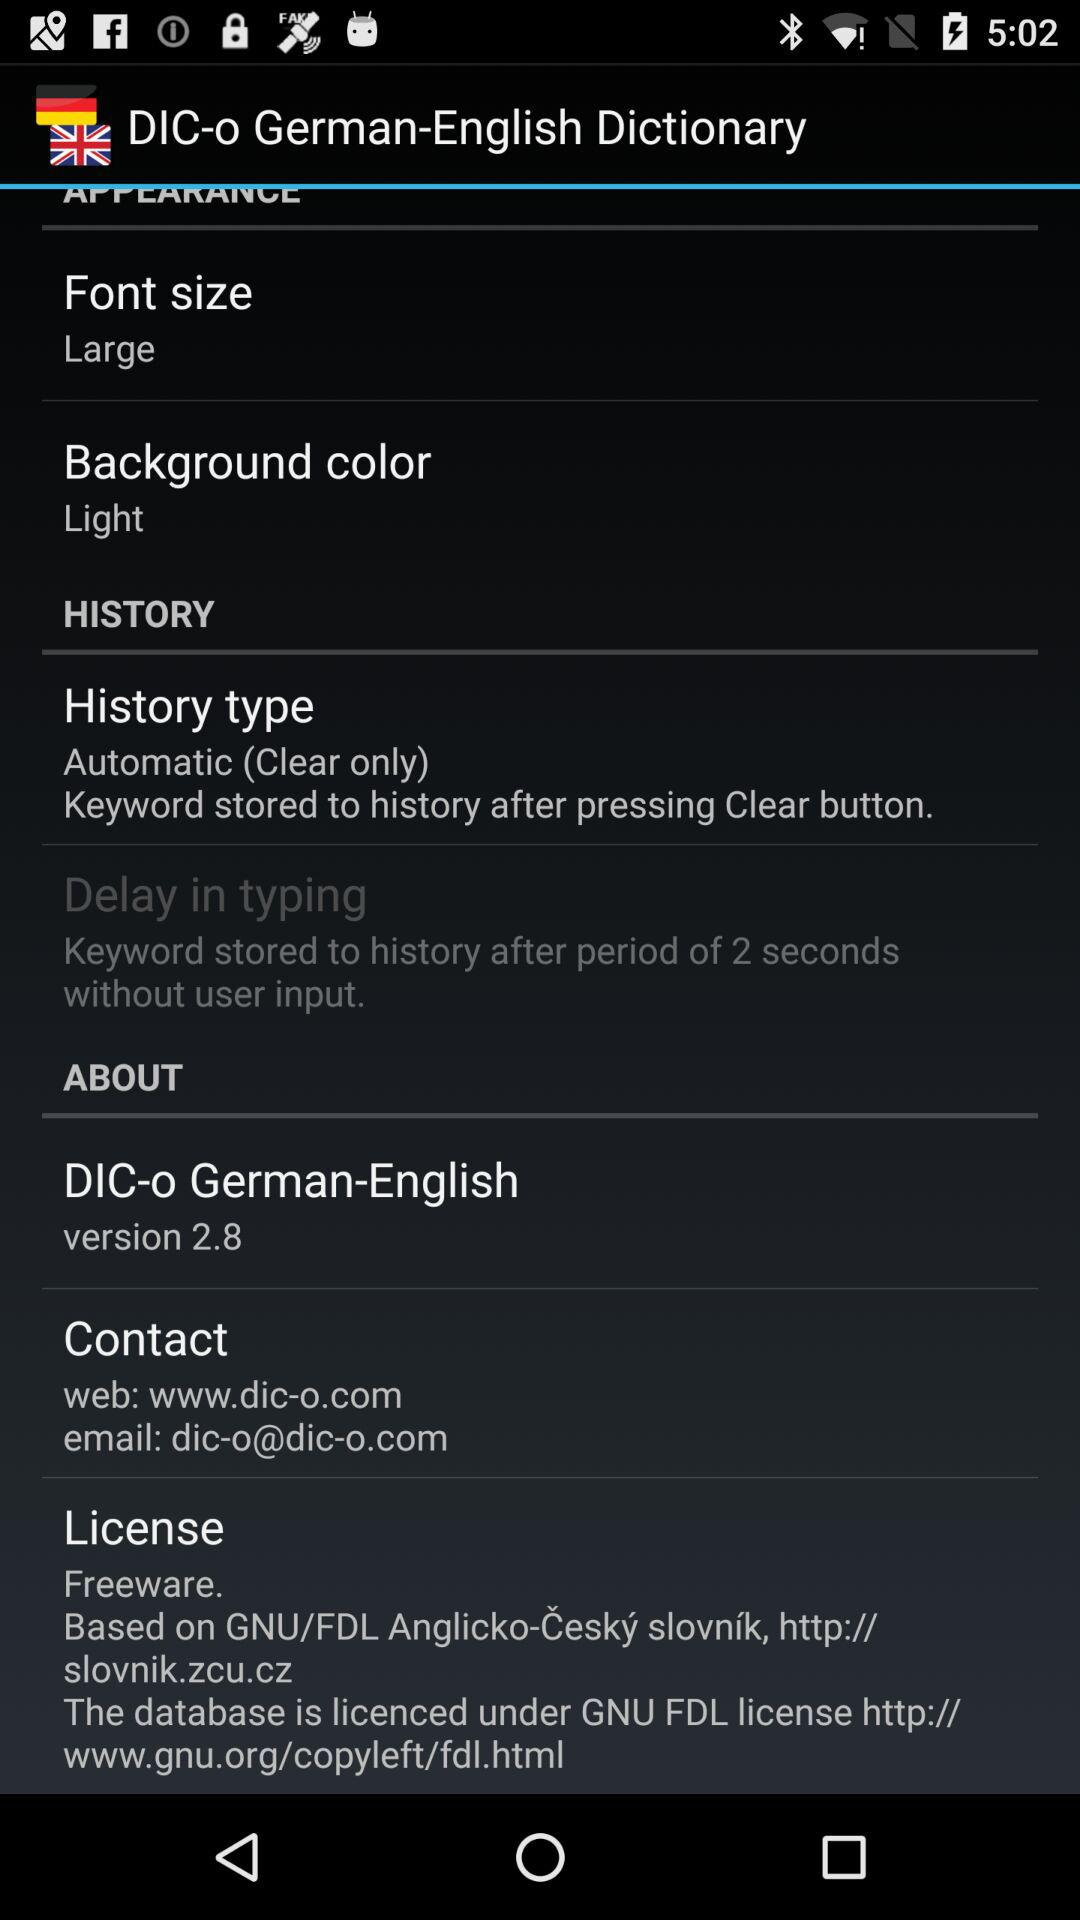What is the selected "History type"? It is automatic (clear only). 